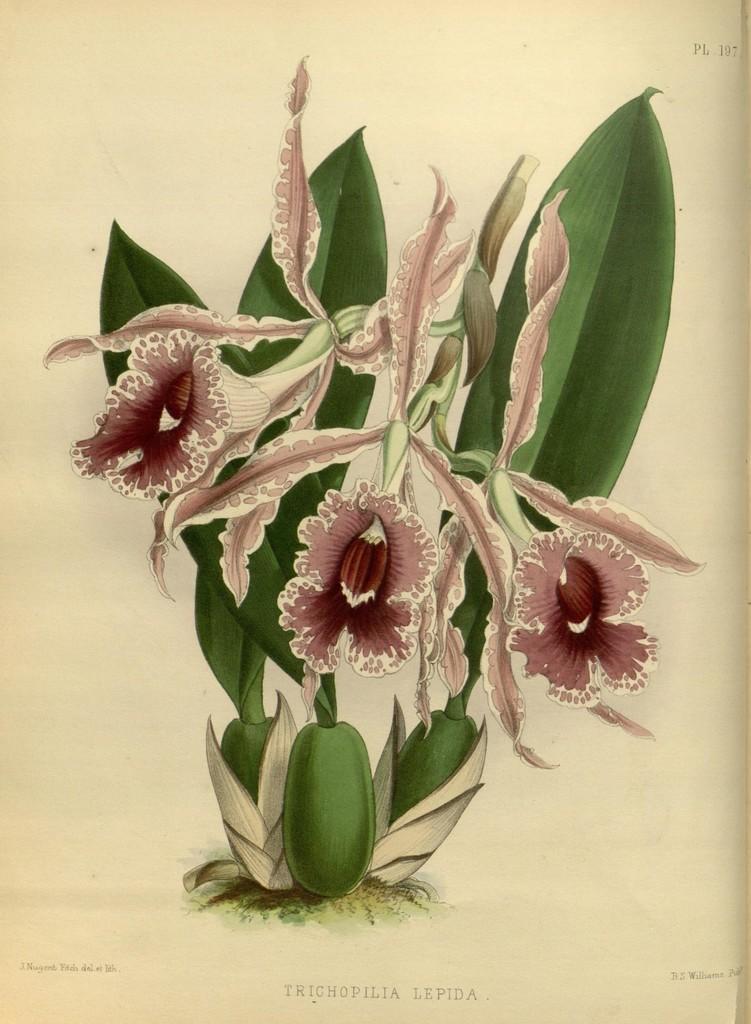How would you summarize this image in a sentence or two? In this image, we can see flowers, leaves and stems. At the bottom and right side top corner, we can see some text and numbers. 